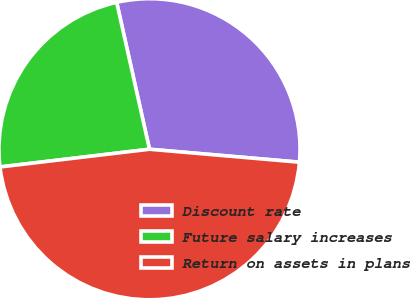Convert chart to OTSL. <chart><loc_0><loc_0><loc_500><loc_500><pie_chart><fcel>Discount rate<fcel>Future salary increases<fcel>Return on assets in plans<nl><fcel>29.87%<fcel>23.38%<fcel>46.75%<nl></chart> 